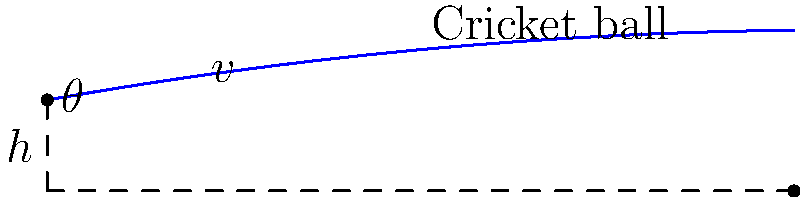In a cricket match at Lord's, a London Spirit bowler releases a ball from a height of 1.8 m with an initial velocity of 30 m/s at an angle of 10° above the horizontal. If the ball has a mass of 0.16 kg, calculate the total energy of the ball at the point of release. Assume g = 9.8 m/s². Let's approach this step-by-step:

1) The total energy of the ball at the point of release is the sum of its kinetic energy (KE) and potential energy (PE).

2) Kinetic Energy:
   $KE = \frac{1}{2}mv^2$
   where m is the mass and v is the velocity.
   $KE = \frac{1}{2} \times 0.16 \times 30^2 = 72$ J

3) Potential Energy:
   $PE = mgh$
   where m is the mass, g is the acceleration due to gravity, and h is the height.
   $PE = 0.16 \times 9.8 \times 1.8 = 2.822$ J

4) Total Energy:
   $E_{total} = KE + PE = 72 + 2.822 = 74.822$ J

Therefore, the total energy of the ball at the point of release is approximately 74.8 J.
Answer: 74.8 J 